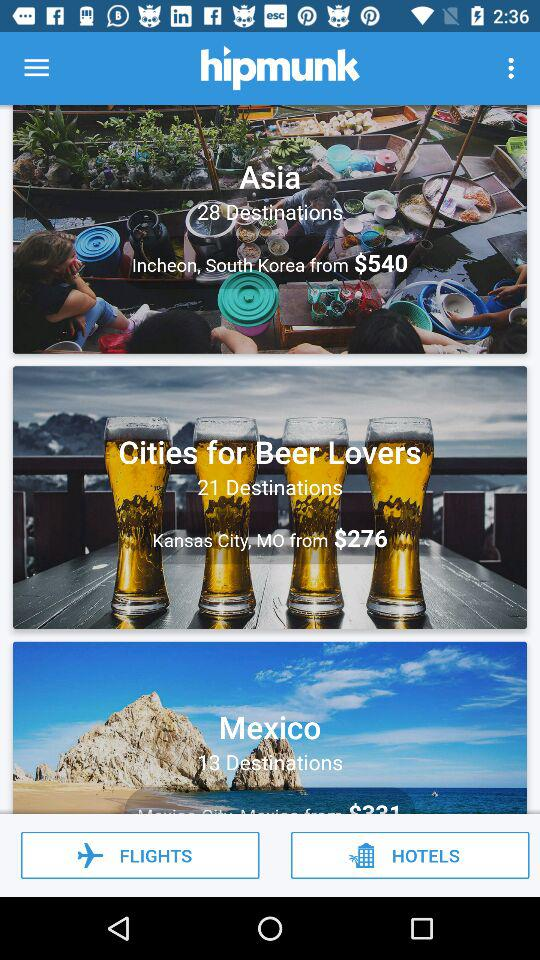Which destination has the lowest price?
Answer the question using a single word or phrase. Kansas City, MO 